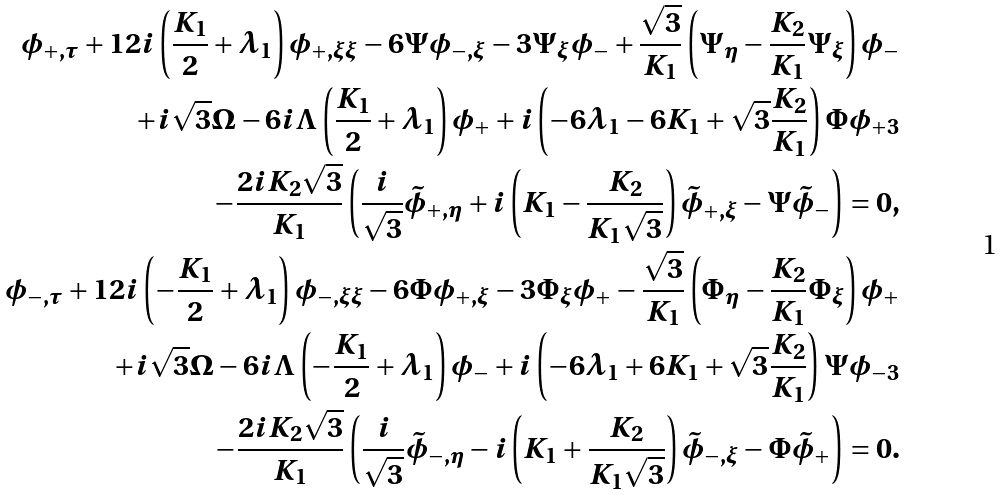Convert formula to latex. <formula><loc_0><loc_0><loc_500><loc_500>\phi _ { + , \tau } + 1 2 i \left ( { \frac { { K _ { 1 } } } { 2 } } + \lambda _ { 1 } \right ) \phi _ { + , \xi \xi } - 6 \Psi \phi _ { - , \xi } - 3 \Psi _ { \xi } \phi _ { - } + { \frac { { \sqrt { 3 } } } { { K _ { 1 } } } } \left ( \Psi _ { \eta } - { \frac { { K _ { 2 } } } { { K _ { 1 } } } } \Psi _ { \xi } \right ) \phi _ { - } \\ + i \sqrt { 3 } \Omega - 6 i \Lambda \left ( { \frac { { K _ { 1 } } } { 2 } } + \lambda _ { 1 } \right ) \phi _ { + } + i \left ( - 6 \lambda _ { 1 } - 6 K _ { 1 } + \sqrt { 3 } { \frac { { K _ { 2 } } } { { K _ { 1 } } } } \right ) \Phi \phi _ { + 3 } \\ - { \frac { { 2 i K _ { 2 } \sqrt { 3 } } } { { K _ { 1 } } } } \left ( { \frac { i } { { \sqrt { 3 } } } } \tilde { \phi } _ { + , \eta } + i \left ( K _ { 1 } - { \frac { { K _ { 2 } } } { { K _ { 1 } \sqrt { 3 } } } } \right ) \tilde { \phi } _ { + , \xi } - \Psi \tilde { \phi } _ { - } \right ) = 0 , \\ \phi _ { - , \tau } + 1 2 i \left ( - { \frac { { K _ { 1 } } } { 2 } } + \lambda _ { 1 } \right ) \phi _ { - , \xi \xi } - 6 \Phi \phi _ { + , \xi } - 3 \Phi _ { \xi } \phi _ { + } - { \frac { { \sqrt { 3 } } } { { K _ { 1 } } } } \left ( \Phi _ { \eta } - { \frac { { K _ { 2 } } } { { K _ { 1 } } } } \Phi _ { \xi } \right ) \phi _ { + } \\ + i \sqrt { 3 } \Omega - 6 i \Lambda \left ( - { \frac { { K _ { 1 } } } { 2 } } + \lambda _ { 1 } \right ) \phi _ { - } + i \left ( - 6 \lambda _ { 1 } + 6 K _ { 1 } + \sqrt { 3 } { \frac { { K _ { 2 } } } { { K _ { 1 } } } } \right ) \Psi \phi _ { - 3 } \\ - { \frac { { 2 i K _ { 2 } \sqrt { 3 } } } { { K _ { 1 } } } } \left ( { \frac { i } { { \sqrt { 3 } } } } \tilde { \phi } _ { - , \eta } - i \left ( K _ { 1 } + { \frac { { K _ { 2 } } } { { K _ { 1 } \sqrt { 3 } } } } \right ) \tilde { \phi } _ { - , \xi } - \Phi \tilde { \phi } _ { + } \right ) = 0 .</formula> 